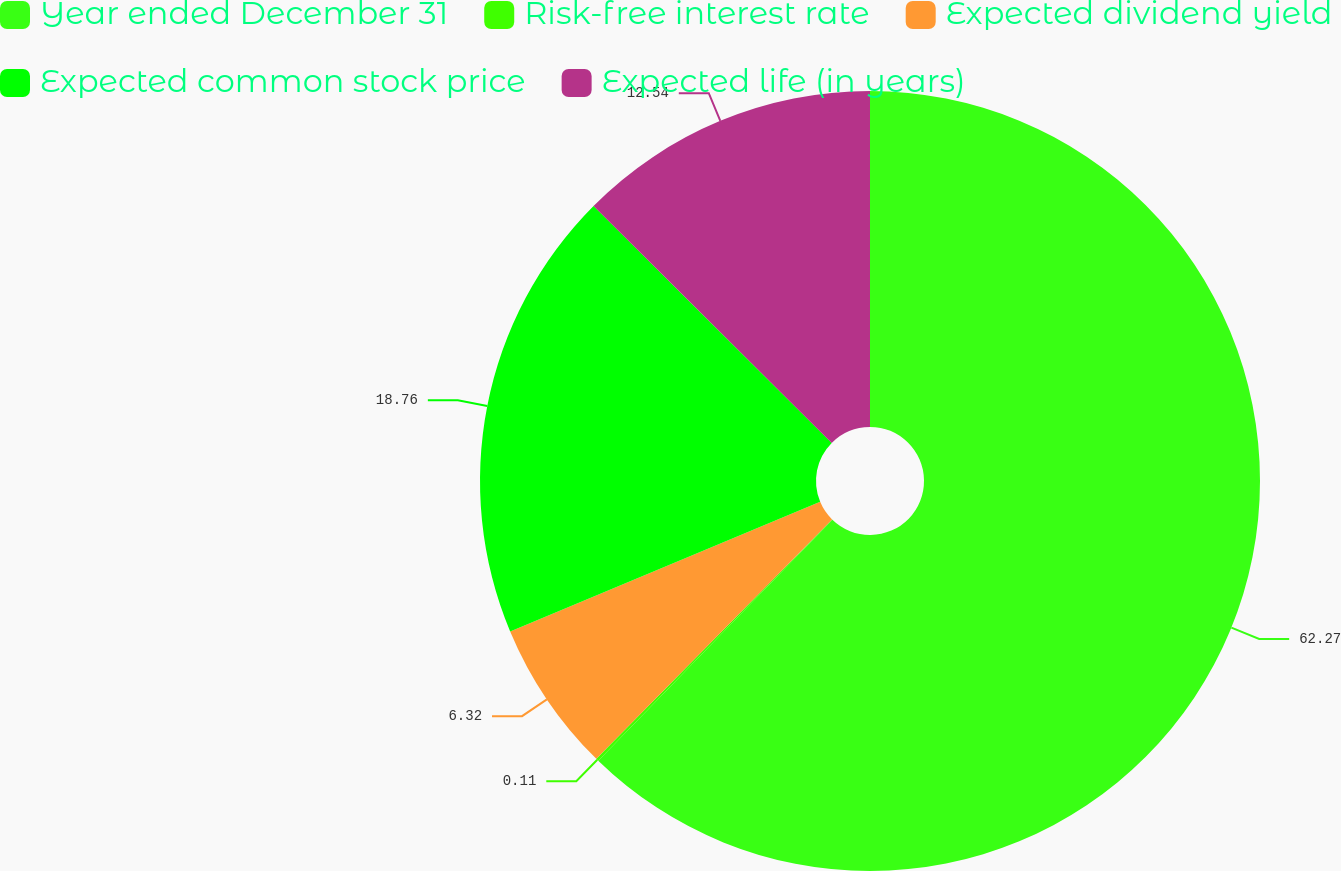Convert chart. <chart><loc_0><loc_0><loc_500><loc_500><pie_chart><fcel>Year ended December 31<fcel>Risk-free interest rate<fcel>Expected dividend yield<fcel>Expected common stock price<fcel>Expected life (in years)<nl><fcel>62.27%<fcel>0.11%<fcel>6.32%<fcel>18.76%<fcel>12.54%<nl></chart> 